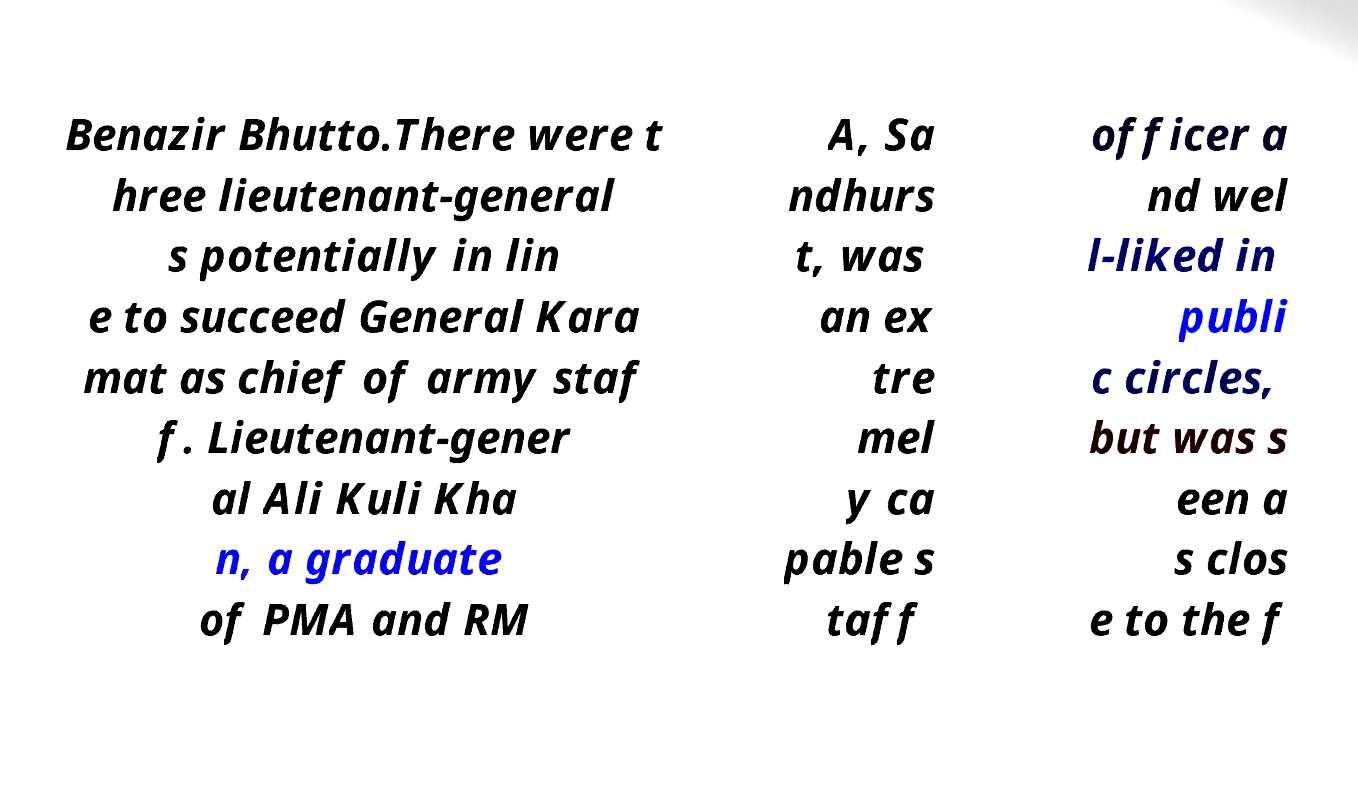There's text embedded in this image that I need extracted. Can you transcribe it verbatim? Benazir Bhutto.There were t hree lieutenant-general s potentially in lin e to succeed General Kara mat as chief of army staf f. Lieutenant-gener al Ali Kuli Kha n, a graduate of PMA and RM A, Sa ndhurs t, was an ex tre mel y ca pable s taff officer a nd wel l-liked in publi c circles, but was s een a s clos e to the f 